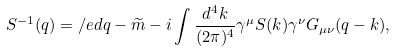Convert formula to latex. <formula><loc_0><loc_0><loc_500><loc_500>S ^ { - 1 } ( q ) = \slash e d { q } - \widetilde { m } - i \int \frac { d ^ { 4 } k } { ( 2 \pi ) ^ { 4 } } \gamma ^ { \mu } S ( k ) \gamma ^ { \nu } G _ { \mu \nu } ( q - k ) ,</formula> 